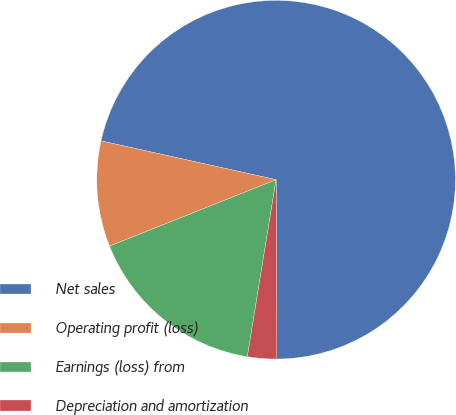<chart> <loc_0><loc_0><loc_500><loc_500><pie_chart><fcel>Net sales<fcel>Operating profit (loss)<fcel>Earnings (loss) from<fcel>Depreciation and amortization<nl><fcel>71.46%<fcel>9.51%<fcel>16.4%<fcel>2.63%<nl></chart> 